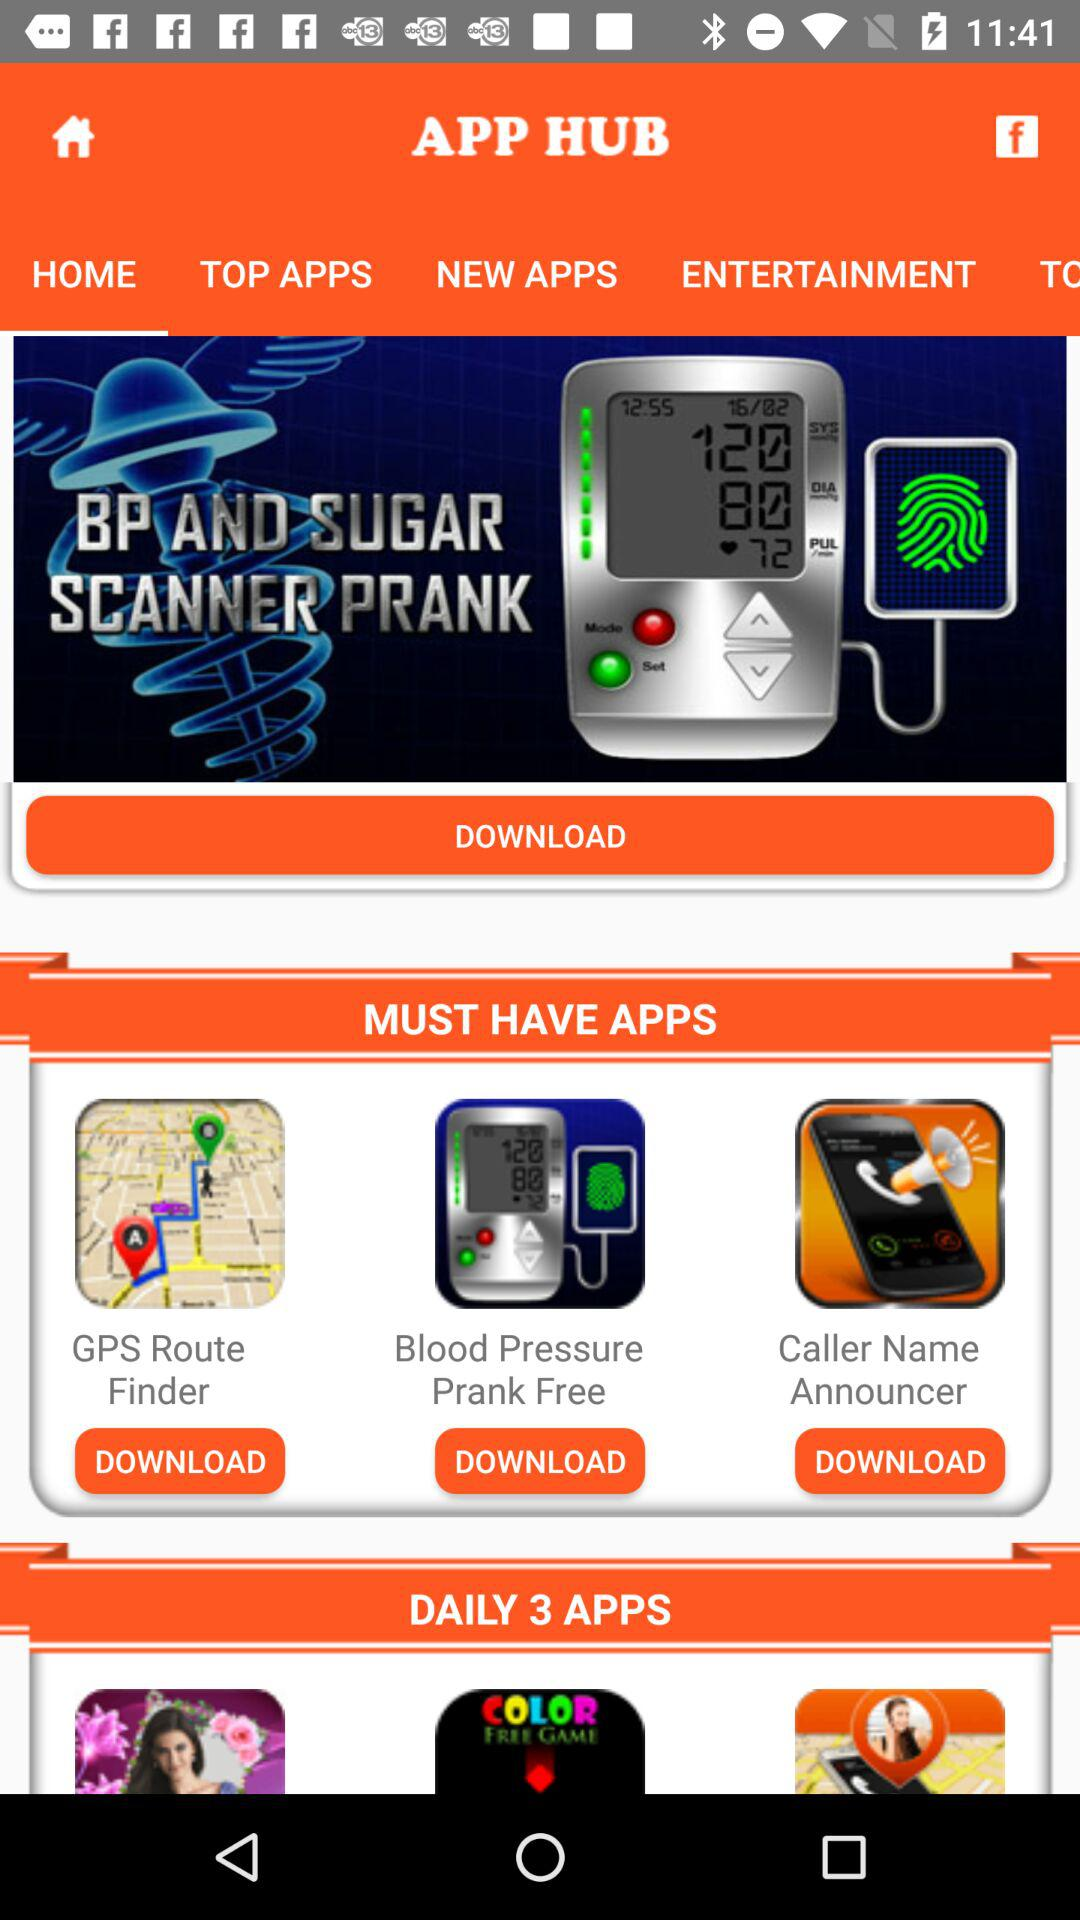Which tab is selected? The selected tab is "HOME". 